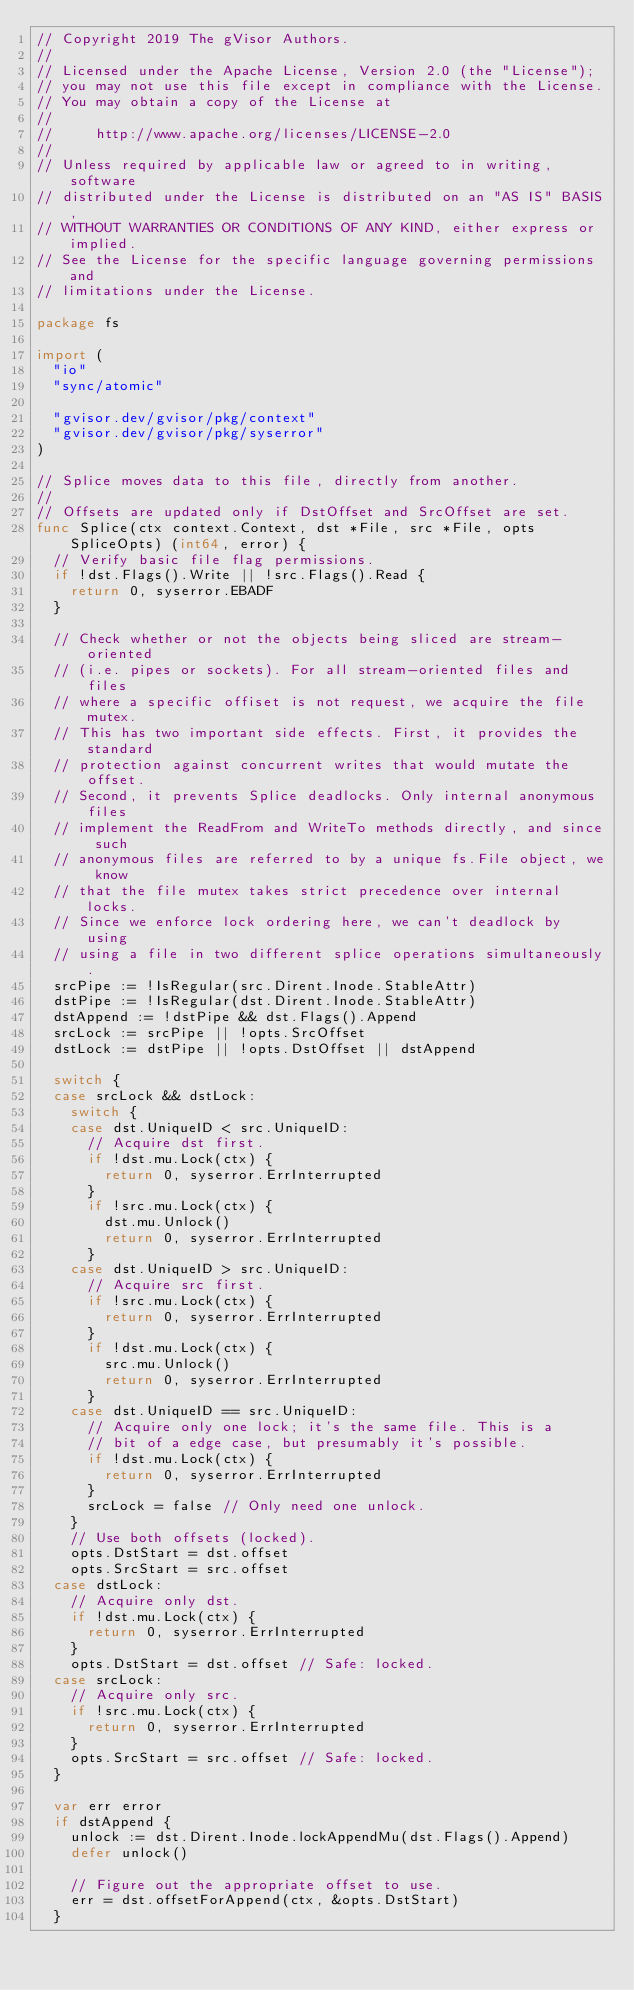Convert code to text. <code><loc_0><loc_0><loc_500><loc_500><_Go_>// Copyright 2019 The gVisor Authors.
//
// Licensed under the Apache License, Version 2.0 (the "License");
// you may not use this file except in compliance with the License.
// You may obtain a copy of the License at
//
//     http://www.apache.org/licenses/LICENSE-2.0
//
// Unless required by applicable law or agreed to in writing, software
// distributed under the License is distributed on an "AS IS" BASIS,
// WITHOUT WARRANTIES OR CONDITIONS OF ANY KIND, either express or implied.
// See the License for the specific language governing permissions and
// limitations under the License.

package fs

import (
	"io"
	"sync/atomic"

	"gvisor.dev/gvisor/pkg/context"
	"gvisor.dev/gvisor/pkg/syserror"
)

// Splice moves data to this file, directly from another.
//
// Offsets are updated only if DstOffset and SrcOffset are set.
func Splice(ctx context.Context, dst *File, src *File, opts SpliceOpts) (int64, error) {
	// Verify basic file flag permissions.
	if !dst.Flags().Write || !src.Flags().Read {
		return 0, syserror.EBADF
	}

	// Check whether or not the objects being sliced are stream-oriented
	// (i.e. pipes or sockets). For all stream-oriented files and files
	// where a specific offiset is not request, we acquire the file mutex.
	// This has two important side effects. First, it provides the standard
	// protection against concurrent writes that would mutate the offset.
	// Second, it prevents Splice deadlocks. Only internal anonymous files
	// implement the ReadFrom and WriteTo methods directly, and since such
	// anonymous files are referred to by a unique fs.File object, we know
	// that the file mutex takes strict precedence over internal locks.
	// Since we enforce lock ordering here, we can't deadlock by using
	// using a file in two different splice operations simultaneously.
	srcPipe := !IsRegular(src.Dirent.Inode.StableAttr)
	dstPipe := !IsRegular(dst.Dirent.Inode.StableAttr)
	dstAppend := !dstPipe && dst.Flags().Append
	srcLock := srcPipe || !opts.SrcOffset
	dstLock := dstPipe || !opts.DstOffset || dstAppend

	switch {
	case srcLock && dstLock:
		switch {
		case dst.UniqueID < src.UniqueID:
			// Acquire dst first.
			if !dst.mu.Lock(ctx) {
				return 0, syserror.ErrInterrupted
			}
			if !src.mu.Lock(ctx) {
				dst.mu.Unlock()
				return 0, syserror.ErrInterrupted
			}
		case dst.UniqueID > src.UniqueID:
			// Acquire src first.
			if !src.mu.Lock(ctx) {
				return 0, syserror.ErrInterrupted
			}
			if !dst.mu.Lock(ctx) {
				src.mu.Unlock()
				return 0, syserror.ErrInterrupted
			}
		case dst.UniqueID == src.UniqueID:
			// Acquire only one lock; it's the same file. This is a
			// bit of a edge case, but presumably it's possible.
			if !dst.mu.Lock(ctx) {
				return 0, syserror.ErrInterrupted
			}
			srcLock = false // Only need one unlock.
		}
		// Use both offsets (locked).
		opts.DstStart = dst.offset
		opts.SrcStart = src.offset
	case dstLock:
		// Acquire only dst.
		if !dst.mu.Lock(ctx) {
			return 0, syserror.ErrInterrupted
		}
		opts.DstStart = dst.offset // Safe: locked.
	case srcLock:
		// Acquire only src.
		if !src.mu.Lock(ctx) {
			return 0, syserror.ErrInterrupted
		}
		opts.SrcStart = src.offset // Safe: locked.
	}

	var err error
	if dstAppend {
		unlock := dst.Dirent.Inode.lockAppendMu(dst.Flags().Append)
		defer unlock()

		// Figure out the appropriate offset to use.
		err = dst.offsetForAppend(ctx, &opts.DstStart)
	}</code> 